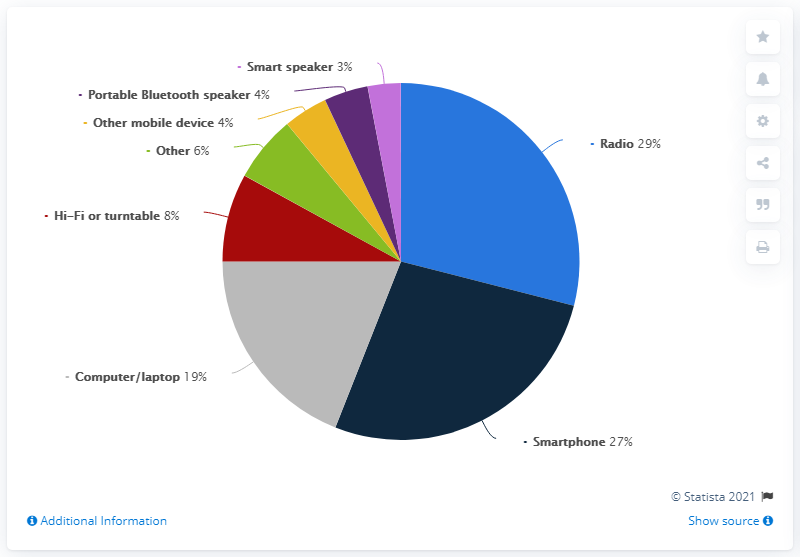Outline some significant characteristics in this image. The result of subtracting the percentage of the least used device from the mode of the four least used devices is a number between 1 and 100. The smallest segment is light purple. 